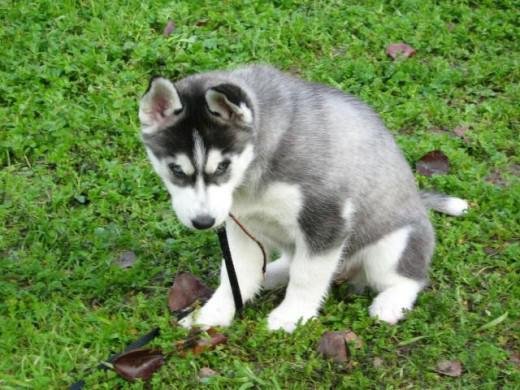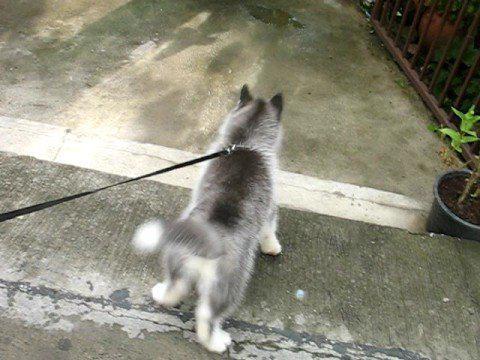The first image is the image on the left, the second image is the image on the right. Considering the images on both sides, is "A dog is sitting in the grass in the image on the left." valid? Answer yes or no. Yes. The first image is the image on the left, the second image is the image on the right. Examine the images to the left and right. Is the description "Each image contains one forward-facing husky in the foreground, at least one dog has blue eyes, and one dog sits upright on green grass." accurate? Answer yes or no. No. 